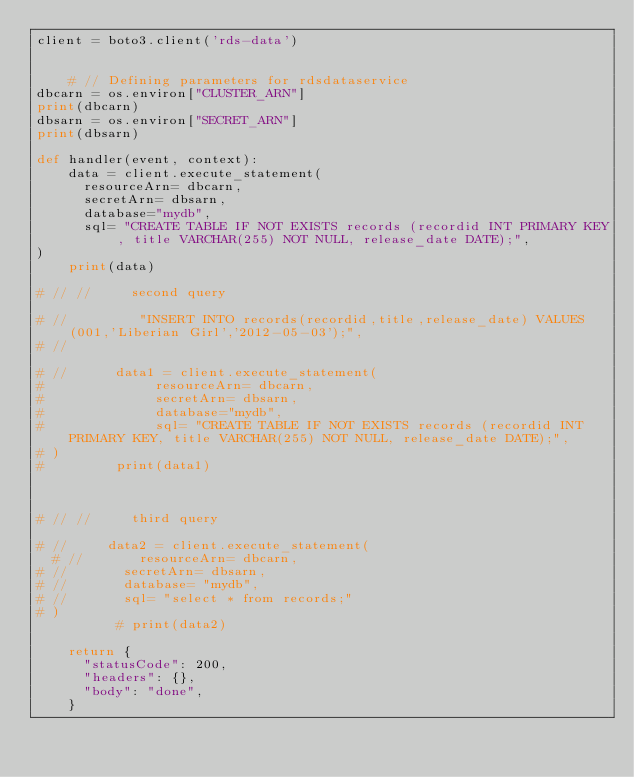<code> <loc_0><loc_0><loc_500><loc_500><_Python_>client = boto3.client('rds-data')


    # // Defining parameters for rdsdataservice
dbcarn = os.environ["CLUSTER_ARN"] 
print(dbcarn)
dbsarn = os.environ["SECRET_ARN"] 
print(dbsarn)

def handler(event, context):   
    data = client.execute_statement(
      resourceArn= dbcarn,
      secretArn= dbsarn,
      database="mydb",
      sql= "CREATE TABLE IF NOT EXISTS records (recordid INT PRIMARY KEY, title VARCHAR(255) NOT NULL, release_date DATE);",
)
    print(data)
    
# // //     second query

# //         "INSERT INTO records(recordid,title,release_date) VALUES(001,'Liberian Girl','2012-05-03');",
# //     

# //      data1 = client.execute_statement( 
#              resourceArn= dbcarn,
#              secretArn= dbsarn,
#              database="mydb",
#              sql= "CREATE TABLE IF NOT EXISTS records (recordid INT PRIMARY KEY, title VARCHAR(255) NOT NULL, release_date DATE);",
# )
#         print(data1)
    
    
    
# // //     third query

# //     data2 = client.execute_statement(
  # //       resourceArn= dbcarn,
# //       secretArn= dbsarn,
# //       database= "mydb",
# //       sql= "select * from records;"
# )
          # print(data2)

    return {
      "statusCode": 200,
      "headers": {},
      "body": "done",
    }
  
</code> 